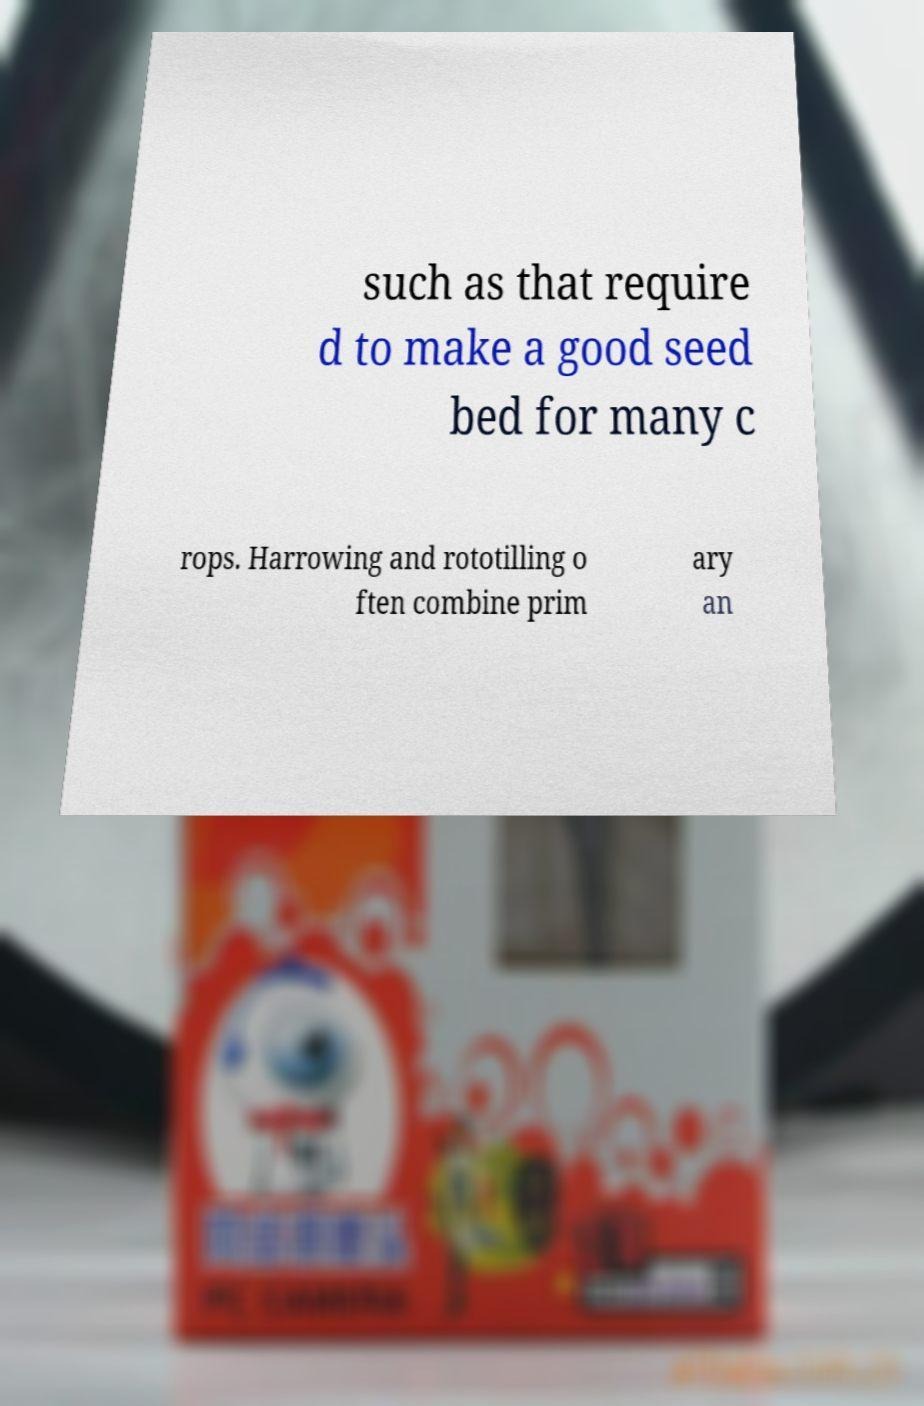For documentation purposes, I need the text within this image transcribed. Could you provide that? such as that require d to make a good seed bed for many c rops. Harrowing and rototilling o ften combine prim ary an 